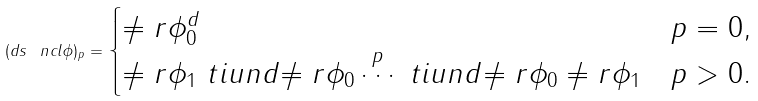<formula> <loc_0><loc_0><loc_500><loc_500>( d s \, \ n c l \phi ) _ { p } = \begin{cases} \ne r \phi _ { 0 } ^ { d } & p = 0 , \\ \ne r \phi _ { 1 } \ t i u n d { \ne r \phi _ { 0 } } \, \overset { p } { \cdots } \, \ t i u n d { \ne r \phi _ { 0 } } \ne r \phi _ { 1 } & p > 0 . \end{cases}</formula> 